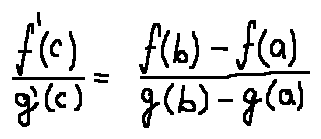<formula> <loc_0><loc_0><loc_500><loc_500>\frac { f ^ { \prime } ( c ) } { g ^ { \prime } ( c ) } = \frac { f ( b ) - f ( a ) } { g ( b ) - g ( a ) }</formula> 